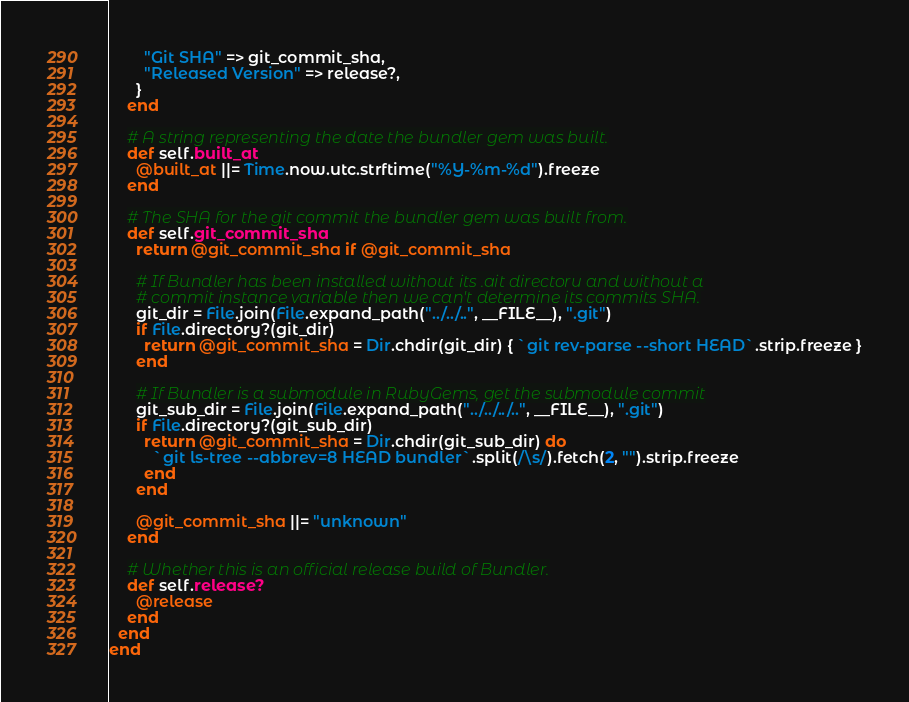Convert code to text. <code><loc_0><loc_0><loc_500><loc_500><_Ruby_>        "Git SHA" => git_commit_sha,
        "Released Version" => release?,
      }
    end

    # A string representing the date the bundler gem was built.
    def self.built_at
      @built_at ||= Time.now.utc.strftime("%Y-%m-%d").freeze
    end

    # The SHA for the git commit the bundler gem was built from.
    def self.git_commit_sha
      return @git_commit_sha if @git_commit_sha

      # If Bundler has been installed without its .git directory and without a
      # commit instance variable then we can't determine its commits SHA.
      git_dir = File.join(File.expand_path("../../..", __FILE__), ".git")
      if File.directory?(git_dir)
        return @git_commit_sha = Dir.chdir(git_dir) { `git rev-parse --short HEAD`.strip.freeze }
      end

      # If Bundler is a submodule in RubyGems, get the submodule commit
      git_sub_dir = File.join(File.expand_path("../../../..", __FILE__), ".git")
      if File.directory?(git_sub_dir)
        return @git_commit_sha = Dir.chdir(git_sub_dir) do
          `git ls-tree --abbrev=8 HEAD bundler`.split(/\s/).fetch(2, "").strip.freeze
        end
      end

      @git_commit_sha ||= "unknown"
    end

    # Whether this is an official release build of Bundler.
    def self.release?
      @release
    end
  end
end
</code> 